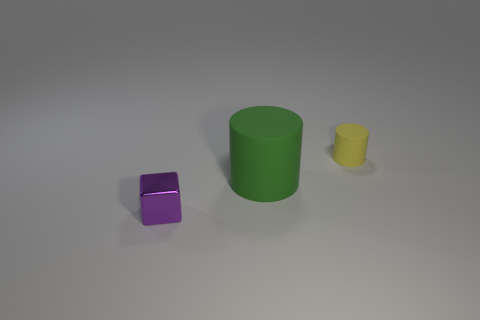What number of green objects are either large objects or matte objects?
Offer a terse response. 1. There is a tiny thing left of the matte object that is to the right of the large rubber thing; is there a thing that is right of it?
Ensure brevity in your answer.  Yes. Is there any other thing that has the same size as the yellow cylinder?
Your answer should be compact. Yes. Does the big object have the same color as the small cylinder?
Your response must be concise. No. There is a tiny object that is in front of the tiny object behind the metallic cube; what is its color?
Make the answer very short. Purple. What number of large objects are metallic blocks or yellow objects?
Your response must be concise. 0. There is a object that is behind the small shiny object and on the left side of the yellow rubber cylinder; what color is it?
Offer a very short reply. Green. Do the large cylinder and the tiny purple block have the same material?
Offer a very short reply. No. What is the shape of the yellow object?
Offer a very short reply. Cylinder. How many small purple cubes are left of the small thing right of the thing that is to the left of the big thing?
Ensure brevity in your answer.  1. 